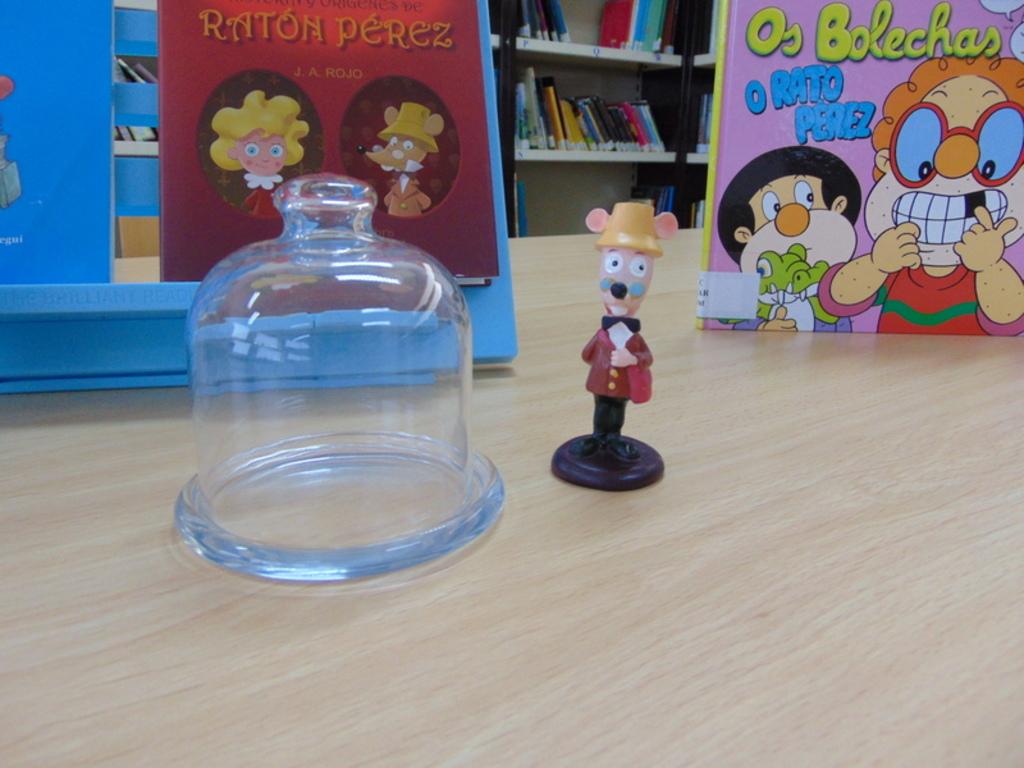Who is the author of the red book?
Your answer should be very brief. Raton perez. What is the pink book titled?
Offer a terse response. Os bolechas. 